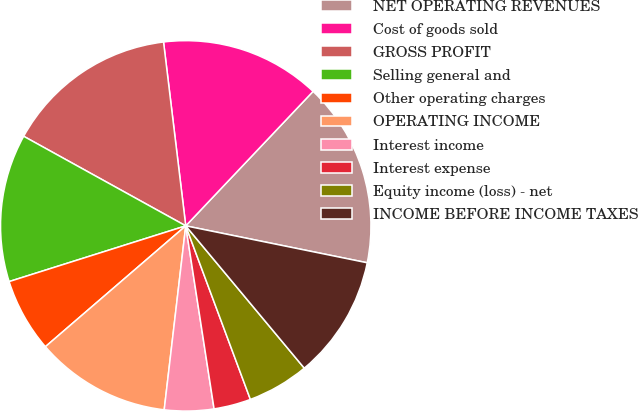<chart> <loc_0><loc_0><loc_500><loc_500><pie_chart><fcel>NET OPERATING REVENUES<fcel>Cost of goods sold<fcel>GROSS PROFIT<fcel>Selling general and<fcel>Other operating charges<fcel>OPERATING INCOME<fcel>Interest income<fcel>Interest expense<fcel>Equity income (loss) - net<fcel>INCOME BEFORE INCOME TAXES<nl><fcel>16.13%<fcel>13.98%<fcel>15.05%<fcel>12.9%<fcel>6.45%<fcel>11.83%<fcel>4.3%<fcel>3.23%<fcel>5.38%<fcel>10.75%<nl></chart> 